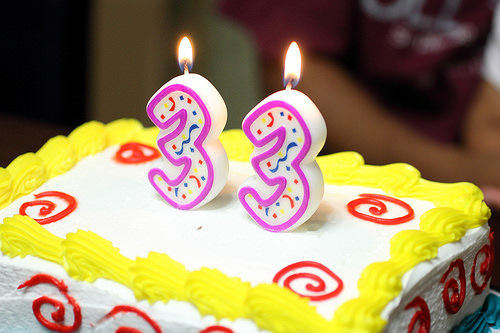<image>
Is there a cake under the handle? Yes. The cake is positioned underneath the handle, with the handle above it in the vertical space. Is there a fire on the cake? Yes. Looking at the image, I can see the fire is positioned on top of the cake, with the cake providing support. 